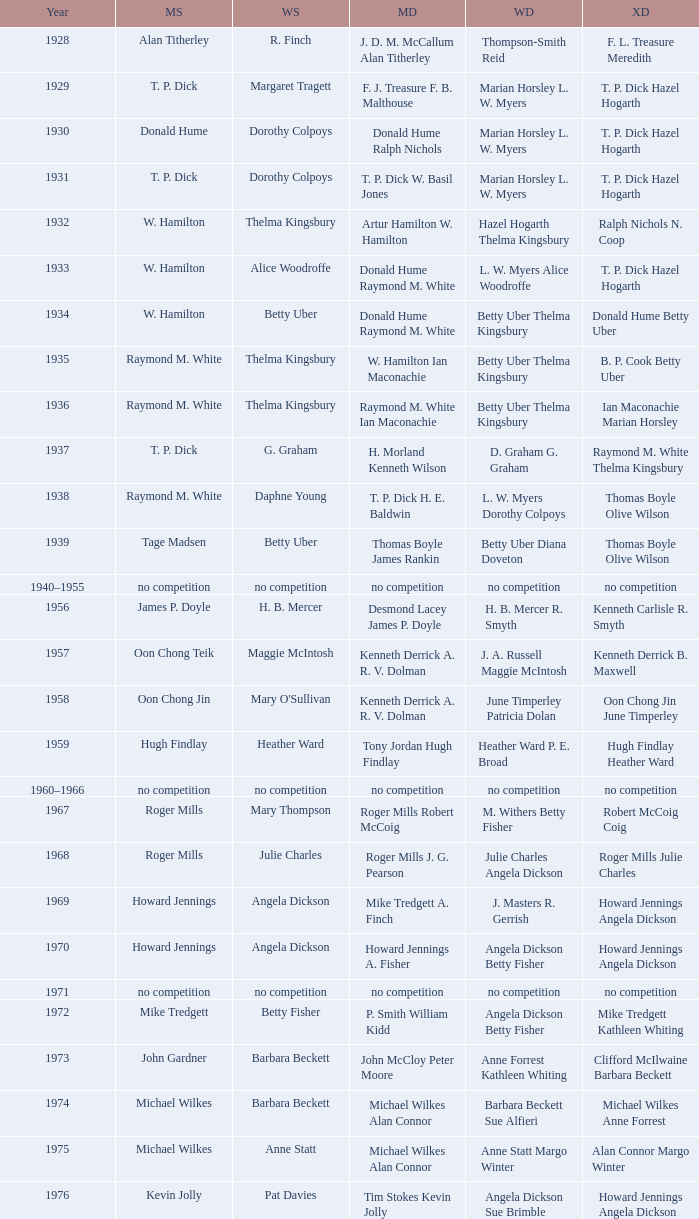Who won the Women's singles, in the year that Raymond M. White won the Men's singles and that W. Hamilton Ian Maconachie won the Men's doubles? Thelma Kingsbury. 